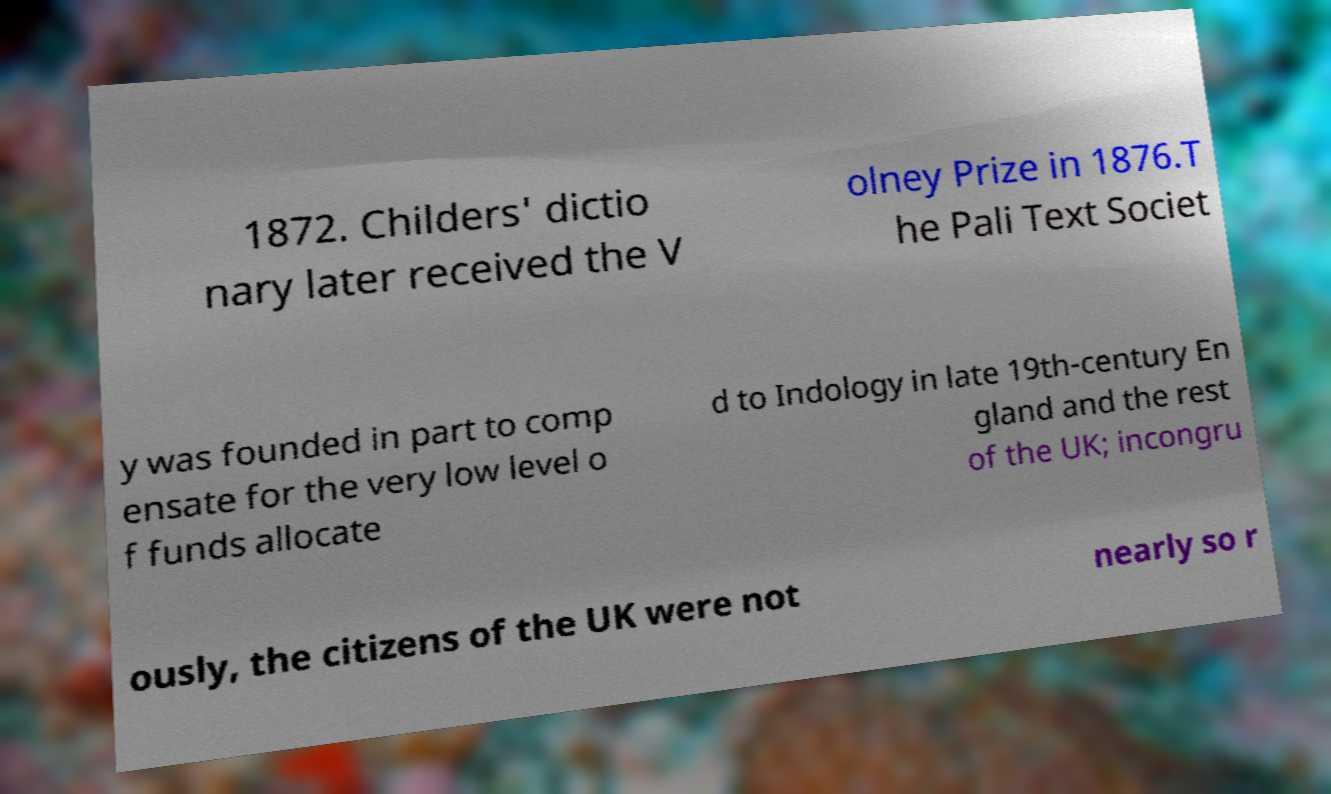Can you accurately transcribe the text from the provided image for me? 1872. Childers' dictio nary later received the V olney Prize in 1876.T he Pali Text Societ y was founded in part to comp ensate for the very low level o f funds allocate d to Indology in late 19th-century En gland and the rest of the UK; incongru ously, the citizens of the UK were not nearly so r 